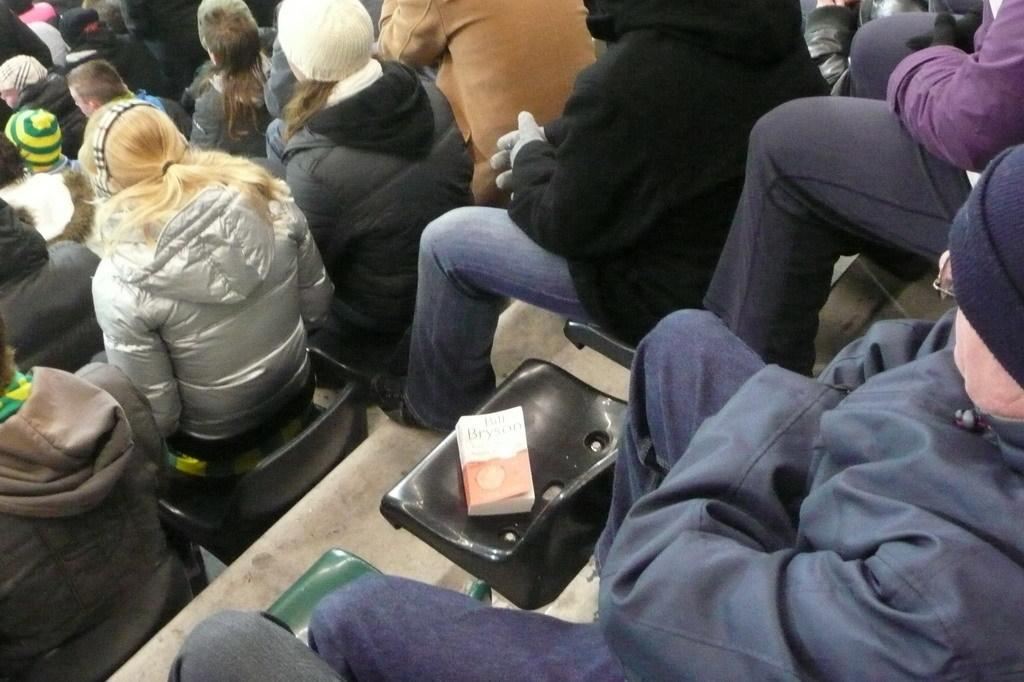How many people are in the image? There are people in the image, but the exact number is not specified. What type of clothing are the people wearing? The people are wearing coats and caps. What are the people doing in the image? The people are sitting on chairs. What object can be seen in the image besides the people? There is a book visible in the image. What architectural feature is present at the bottom of the image? There are stairs at the bottom of the image. What type of dinosaur is sitting next to the person on the left in the image? There are no dinosaurs present in the image; it features people wearing coats and caps, sitting on chairs, and a book visible. 